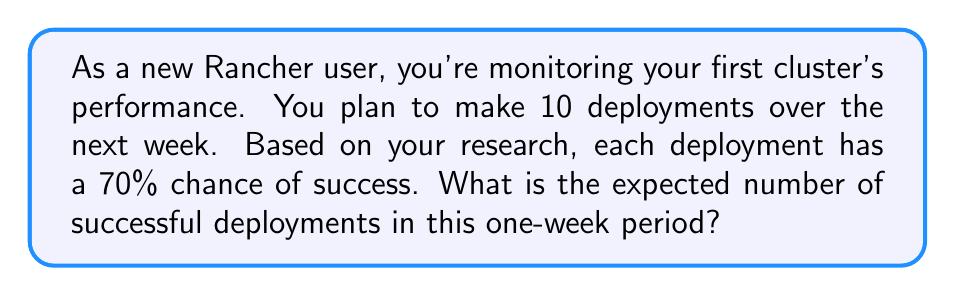Can you answer this question? Let's approach this step-by-step:

1) First, we need to understand what "expected value" means. In probability theory, the expected value of a random variable is the sum of all possible values, each multiplied by its probability of occurrence.

2) In this case, we have a binomial probability distribution. Each deployment is an independent event with two possible outcomes: success (probability 0.7) or failure (probability 0.3).

3) For a binomial distribution, the expected value is calculated by multiplying the number of trials by the probability of success for each trial.

4) We can express this mathematically as:

   $$ E(X) = n \cdot p $$

   Where:
   $E(X)$ is the expected value
   $n$ is the number of trials (deployments)
   $p$ is the probability of success for each trial

5) Plugging in our values:
   $n = 10$ (number of deployments)
   $p = 0.7$ (70% chance of success)

6) Calculating:
   $$ E(X) = 10 \cdot 0.7 = 7 $$

Therefore, the expected number of successful deployments is 7.
Answer: 7 successful deployments 